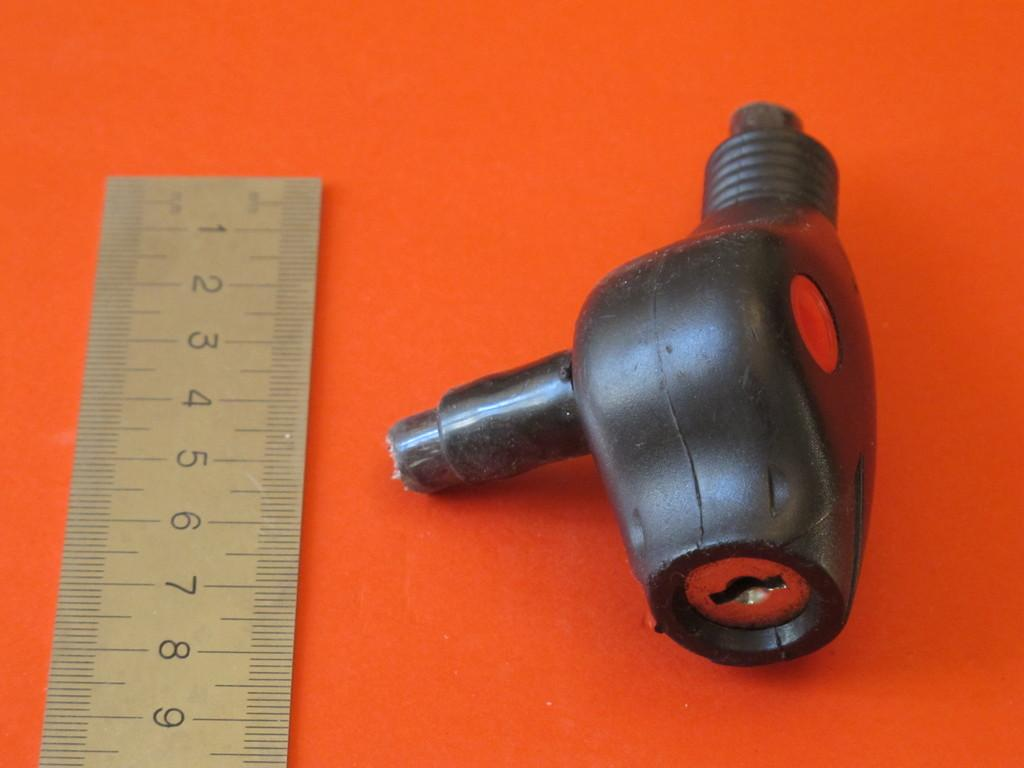<image>
Share a concise interpretation of the image provided. Black object being measured on a ruler that goes up to number 9. 